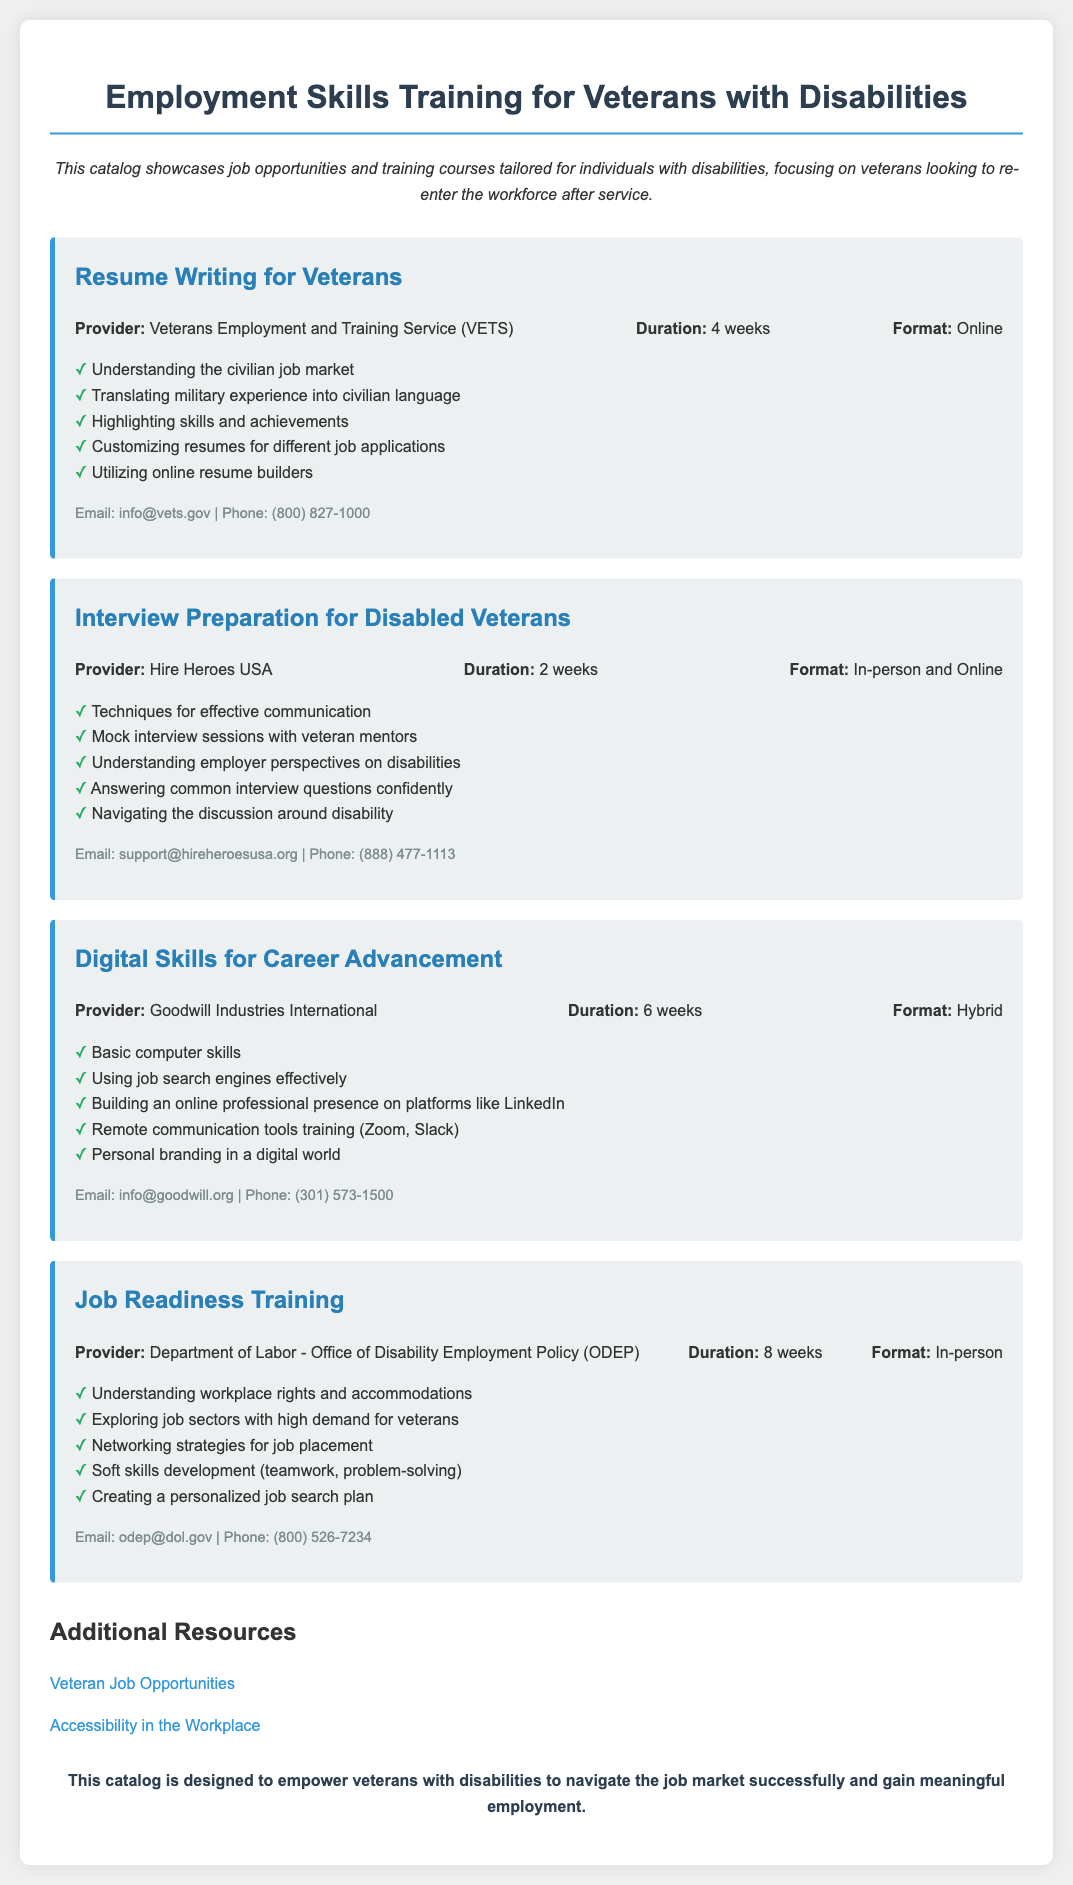What is the title of the catalog? The title is stated at the top of the document as "Employment Skills Training for Veterans with Disabilities."
Answer: Employment Skills Training for Veterans with Disabilities What is the duration of the Resume Writing course? The duration of the Resume Writing course is mentioned as 4 weeks.
Answer: 4 weeks Who provides the Interview Preparation course? The document specifies that the Interview Preparation course is provided by Hire Heroes USA.
Answer: Hire Heroes USA How many weeks is the Job Readiness Training? The duration of the Job Readiness Training is listed as 8 weeks.
Answer: 8 weeks What is a topic covered in the Digital Skills for Career Advancement course? The document lists "Using job search engines effectively" as one of the topics in the Digital Skills for Career Advancement course.
Answer: Using job search engines effectively What types of course formats are available? Multiple formats are mentioned such as Online, In-person, and Hybrid for different courses in the catalog.
Answer: Online, In-person, Hybrid What email can be used to contact the Department of Labor - ODEP? The contact email for the Department of Labor - ODEP is provided in the course details.
Answer: odep@dol.gov List one additional resource mentioned in the catalog. The catalog includes a link to "Veteran Job Opportunities" as one of its additional resources.
Answer: Veteran Job Opportunities What key skill is developed in the Job Readiness Training? "Soft skills development (teamwork, problem-solving)" is mentioned as a key skill developed in the Job Readiness Training.
Answer: Soft skills development (teamwork, problem-solving) 